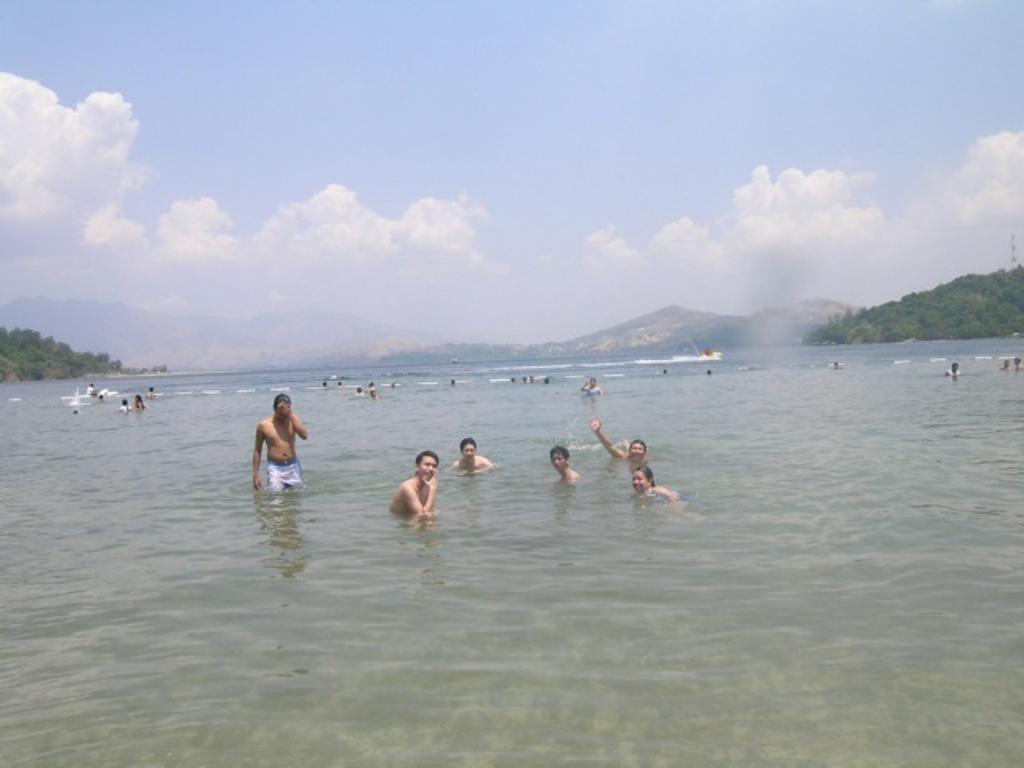Could you give a brief overview of what you see in this image? In this picture we can see so many people are playing in the water, around we can see some trees and hills. 